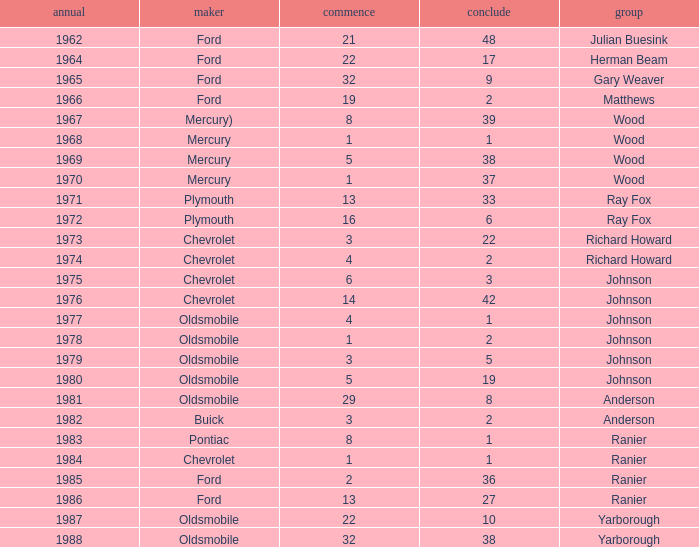What is the smallest finish time for a race after 1972 with a car manufactured by pontiac? 1.0. 